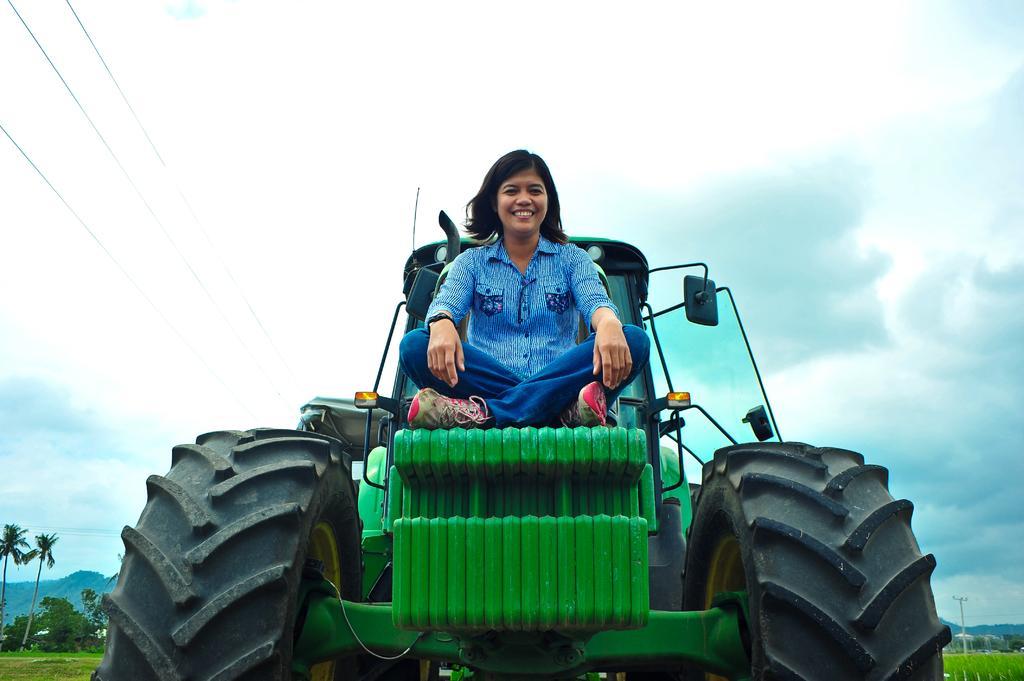Please provide a concise description of this image. In this image we can see a person sitting on a vehicle. In the bottom right we can see a pole, grass, trees and mountains. In the bottom left we can see trees, grass and mountains. At the top we can see the sky and wires. 